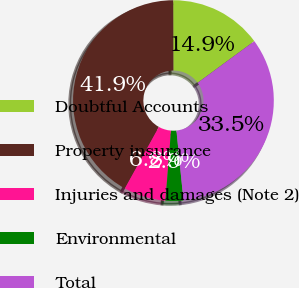Convert chart. <chart><loc_0><loc_0><loc_500><loc_500><pie_chart><fcel>Doubtful Accounts<fcel>Property insurance<fcel>Injuries and damages (Note 2)<fcel>Environmental<fcel>Total<nl><fcel>14.95%<fcel>41.92%<fcel>6.77%<fcel>2.87%<fcel>33.49%<nl></chart> 